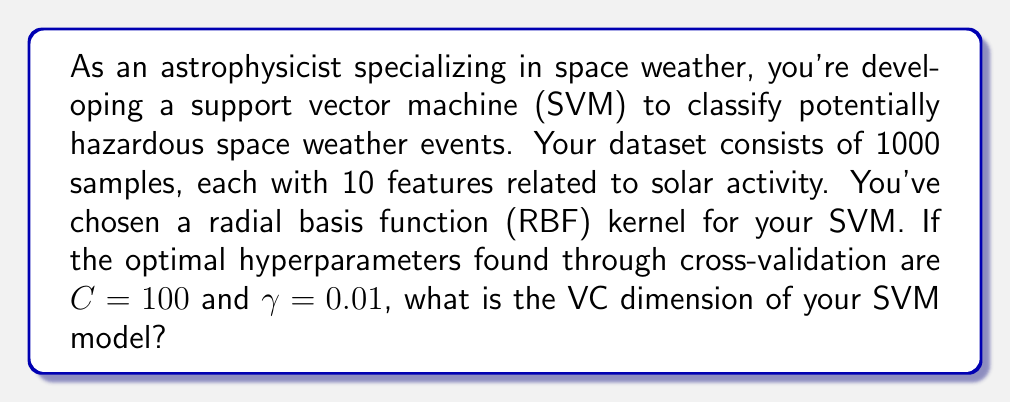Help me with this question. To solve this problem, we need to understand the relationship between the VC dimension of an SVM with an RBF kernel and its hyperparameters. The VC dimension is a measure of a model's capacity to fit a wide range of functions.

For an SVM with an RBF kernel, the VC dimension is approximately:

$$ VC_{SVM-RBF} \approx min\left(n, \frac{R^2}{\gamma}\right) + 1 $$

Where:
- $n$ is the number of features
- $R$ is the radius of the smallest sphere enclosing the data in feature space
- $\gamma$ is the RBF kernel parameter

Given:
- Number of features, $n = 10$
- $\gamma = 0.01$

We need to estimate $R$. In practice, $R$ is often approximated as $R \approx \sqrt{n}$. So:

$$ R \approx \sqrt{10} \approx 3.16 $$

Now we can calculate the VC dimension:

$$ VC_{SVM-RBF} \approx min\left(10, \frac{3.16^2}{0.01}\right) + 1 $$

$$ VC_{SVM-RBF} \approx min\left(10, 998.56\right) + 1 $$

$$ VC_{SVM-RBF} \approx 10 + 1 = 11 $$

The $C$ parameter doesn't directly affect the VC dimension calculation, but it influences the model's ability to use its full capacity.
Answer: 11 